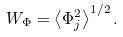Convert formula to latex. <formula><loc_0><loc_0><loc_500><loc_500>W _ { \Phi } = \left \langle \Phi _ { j } ^ { 2 } \right \rangle ^ { 1 / 2 } .</formula> 